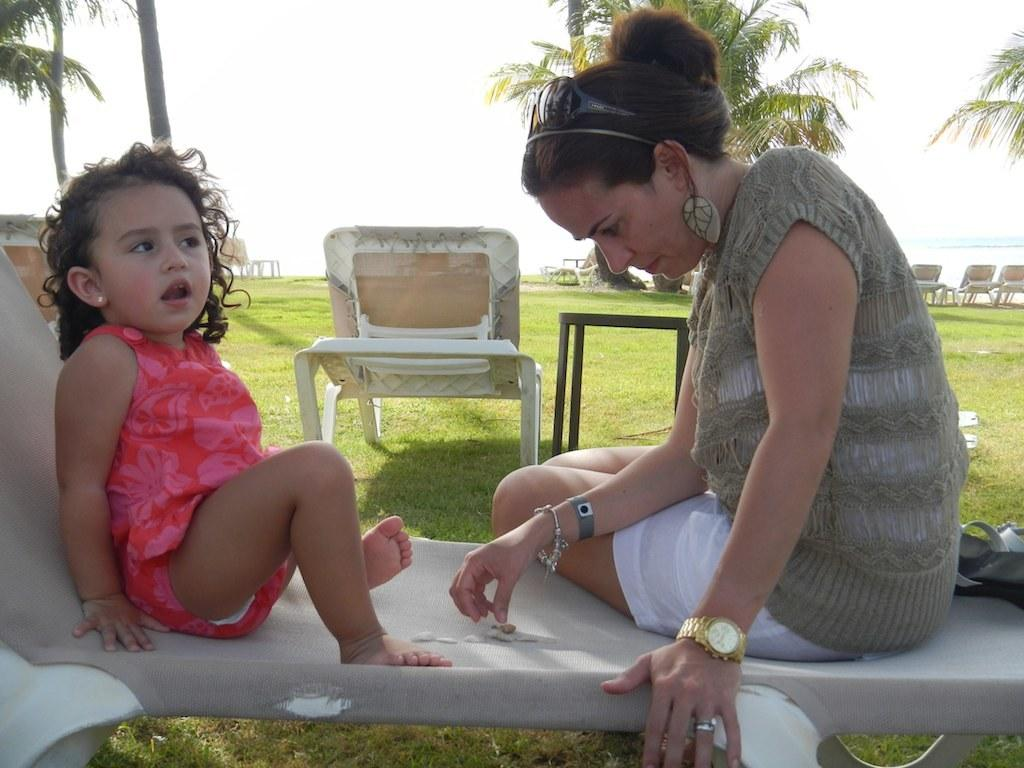How many people are sitting in the image? There are two people sitting on chairs in the image. What else can be seen in the image besides the people? Additional chairs are visible in the image. What type of natural environment is visible in the background of the image? Trees, grass, a lake, and the sky are visible in the background of the image. What type of bat can be seen flying over the lake in the image? There is no bat visible in the image; only trees, grass, a lake, and the sky are present in the background. 